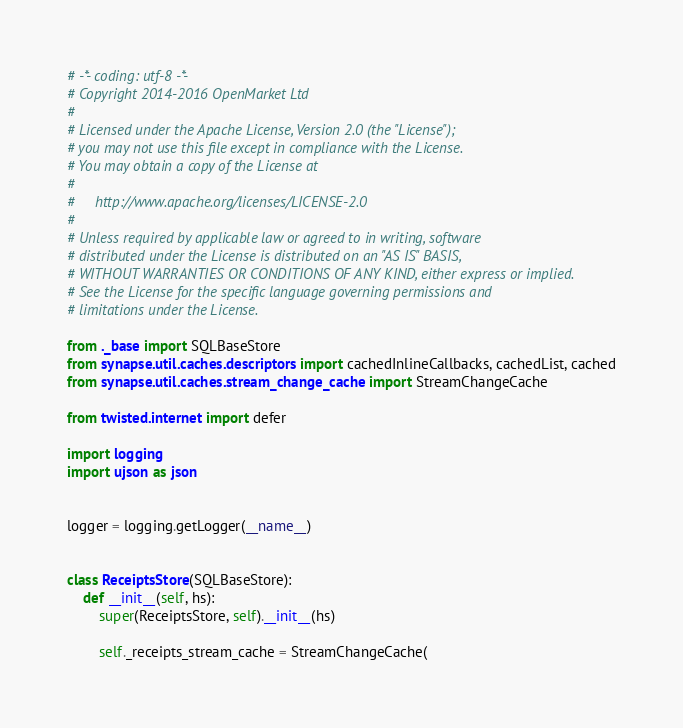Convert code to text. <code><loc_0><loc_0><loc_500><loc_500><_Python_># -*- coding: utf-8 -*-
# Copyright 2014-2016 OpenMarket Ltd
#
# Licensed under the Apache License, Version 2.0 (the "License");
# you may not use this file except in compliance with the License.
# You may obtain a copy of the License at
#
#     http://www.apache.org/licenses/LICENSE-2.0
#
# Unless required by applicable law or agreed to in writing, software
# distributed under the License is distributed on an "AS IS" BASIS,
# WITHOUT WARRANTIES OR CONDITIONS OF ANY KIND, either express or implied.
# See the License for the specific language governing permissions and
# limitations under the License.

from ._base import SQLBaseStore
from synapse.util.caches.descriptors import cachedInlineCallbacks, cachedList, cached
from synapse.util.caches.stream_change_cache import StreamChangeCache

from twisted.internet import defer

import logging
import ujson as json


logger = logging.getLogger(__name__)


class ReceiptsStore(SQLBaseStore):
    def __init__(self, hs):
        super(ReceiptsStore, self).__init__(hs)

        self._receipts_stream_cache = StreamChangeCache(</code> 